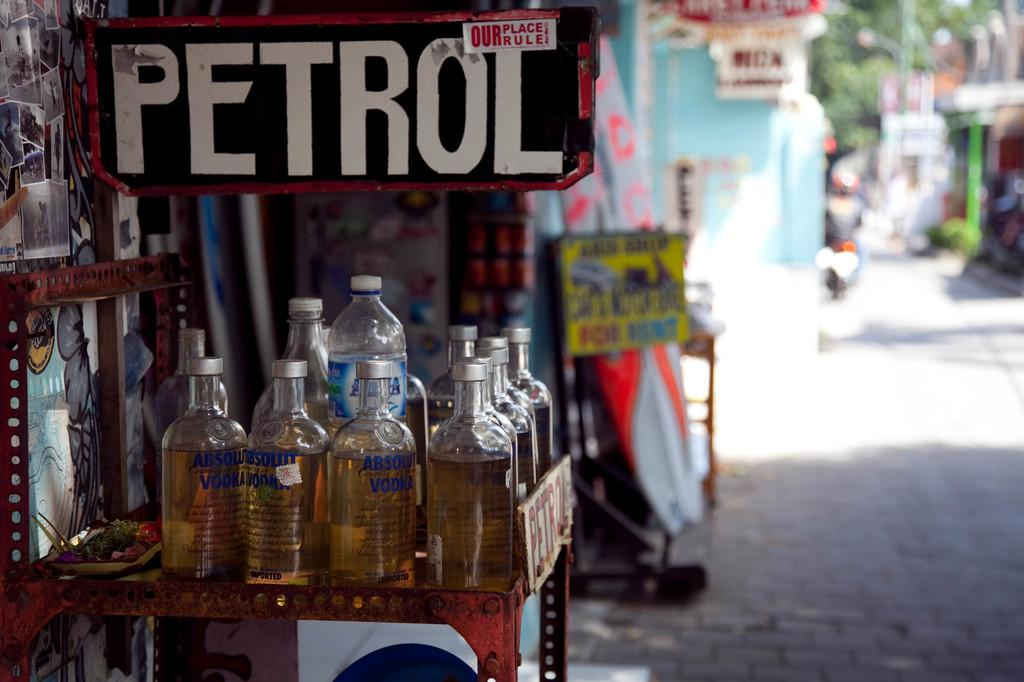Provide a one-sentence caption for the provided image. Several bottles of Absolute Vodka are on a table under a sign that reads PETROL. 